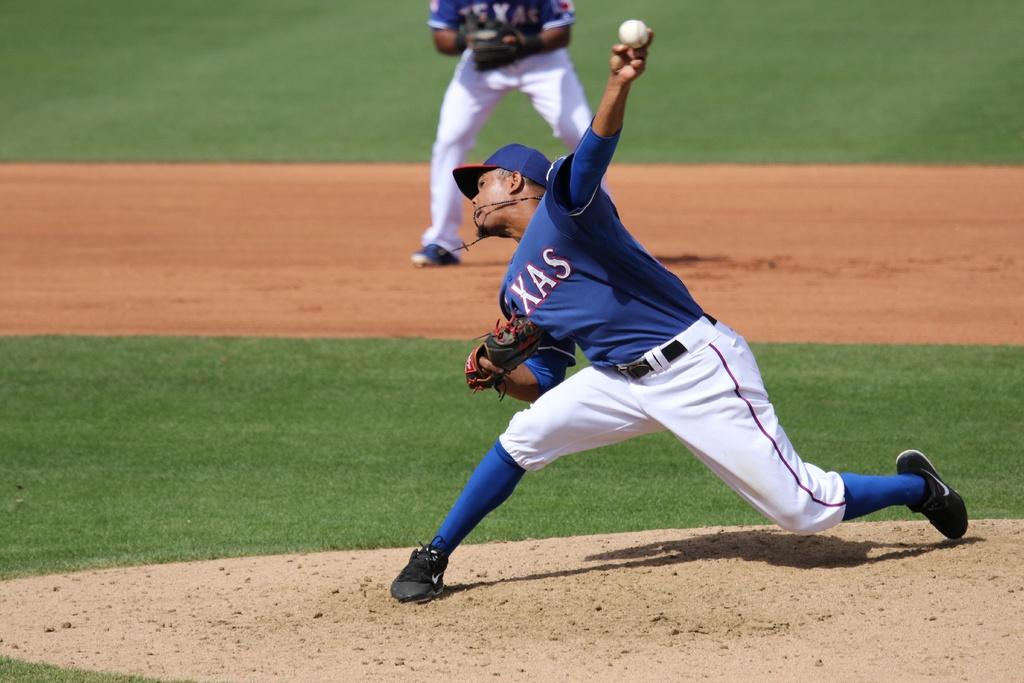<image>
Summarize the visual content of the image. a Texas pitcher throwing a baseball on the mound 